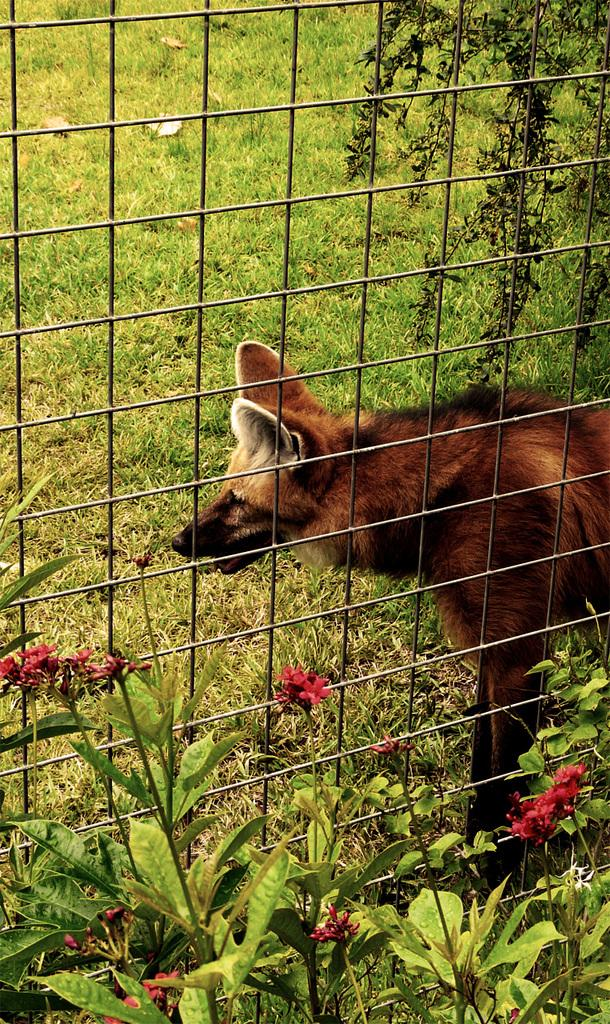What type of animal is in the image? There is a dog in the image. Where is the dog located in relation to other objects? The dog is standing near a steel net. What type of vegetation can be seen at the bottom of the image? Flowers and plants are visible at the bottom of the image. What type of ground surface is present in the image? Grass is present in the image. What color of polish is the dog wearing on its paws in the image? There is no mention of polish or any color on the dog's paws in the image. 